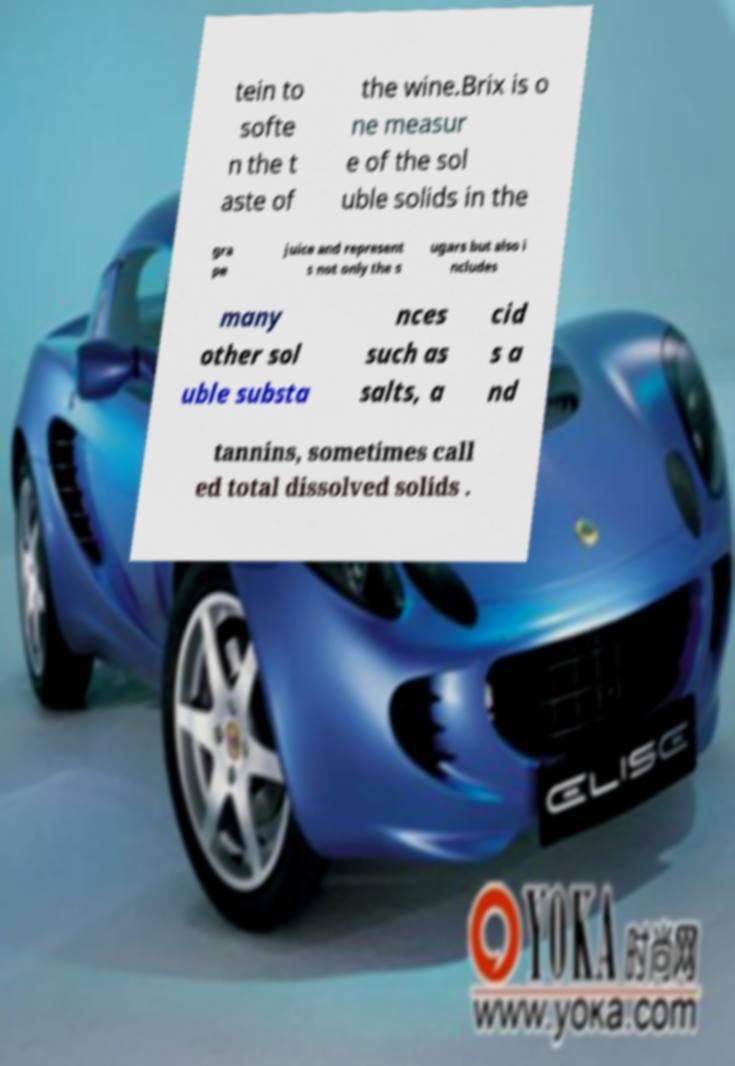Please read and relay the text visible in this image. What does it say? tein to softe n the t aste of the wine.Brix is o ne measur e of the sol uble solids in the gra pe juice and represent s not only the s ugars but also i ncludes many other sol uble substa nces such as salts, a cid s a nd tannins, sometimes call ed total dissolved solids . 